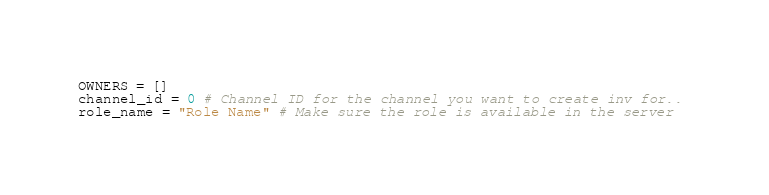Convert code to text. <code><loc_0><loc_0><loc_500><loc_500><_Python_>OWNERS = []
channel_id = 0 # Channel ID for the channel you want to create inv for.. 
role_name = "Role Name" # Make sure the role is available in the server</code> 